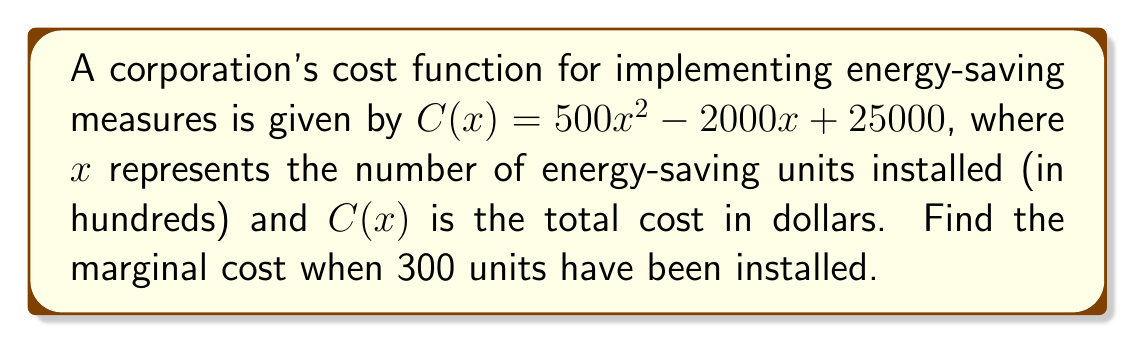Can you answer this question? To find the marginal cost, we need to calculate the derivative of the cost function $C(x)$ and evaluate it at $x = 3$ (since 300 units = 3 hundreds of units).

1) The cost function is $C(x) = 500x^2 - 2000x + 25000$

2) To find the derivative $C'(x)$, we apply the power rule and constant rule:
   $$C'(x) = 1000x - 2000$$

3) The marginal cost is given by $C'(x)$, which represents the rate of change of the total cost with respect to the number of units installed.

4) To find the marginal cost at 300 units, we substitute $x = 3$ into $C'(x)$:
   $$C'(3) = 1000(3) - 2000 = 3000 - 2000 = 1000$$

5) Therefore, the marginal cost when 300 units have been installed is $1000 dollars per hundred units, or $10 per unit.
Answer: $1000 per hundred units 